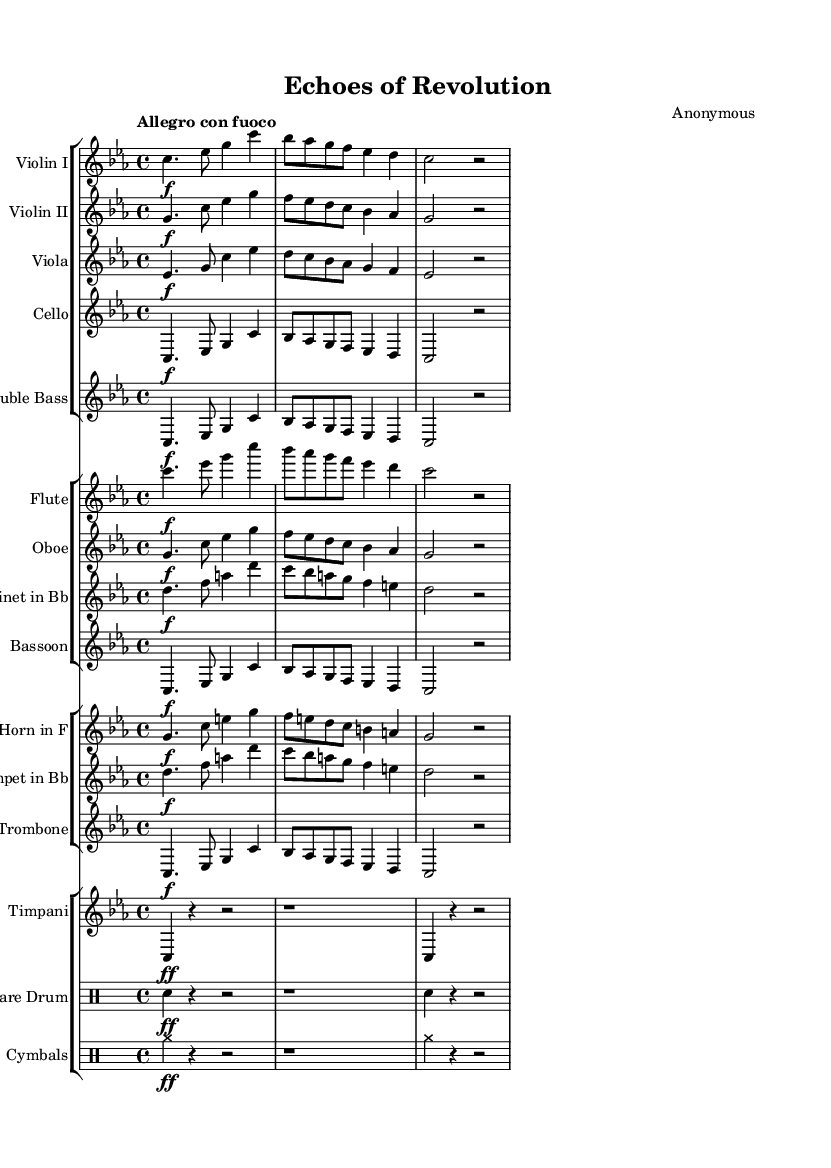What is the key signature of this music? The key signature is indicated by the presence of three flat signs (B♭, E♭, and A♭), which confirms that the piece is in C minor.
Answer: C minor What is the time signature of this music? The time signature is given at the beginning of the score as 4/4, which means there are four beats in each measure, and a quarter note gets one beat.
Answer: 4/4 What is the tempo marking for this symphony? The tempo marking is indicated as "Allegro con fuoco," suggesting a fast and fiery pace of performance.
Answer: Allegro con fuoco Which instruments are playing the main melody? The main melody is primarily assigned to the Violins I and II, while the other orchestral instruments provide harmonic support and counter-melodies.
Answer: Violins I and II How many distinct staff groups are there in this piece? The score consists of four distinct staff groups: strings, woodwinds, brass, and percussion, with each group containing various instruments.
Answer: Four Identify the role of the timpani in this composition. The timpani provides rhythmic emphasis and accents in the symphony, characterized by its strong beats indicated by the notated notes and rests, contributing to the dramatic flair of the piece.
Answer: Rhythmic emphasis What is the specific dynamic marking at the beginning of the cello part? The cello part begins with a forte dynamic marking, indicated by the symbol "f," which instructs the player to play loudly.
Answer: Forte 